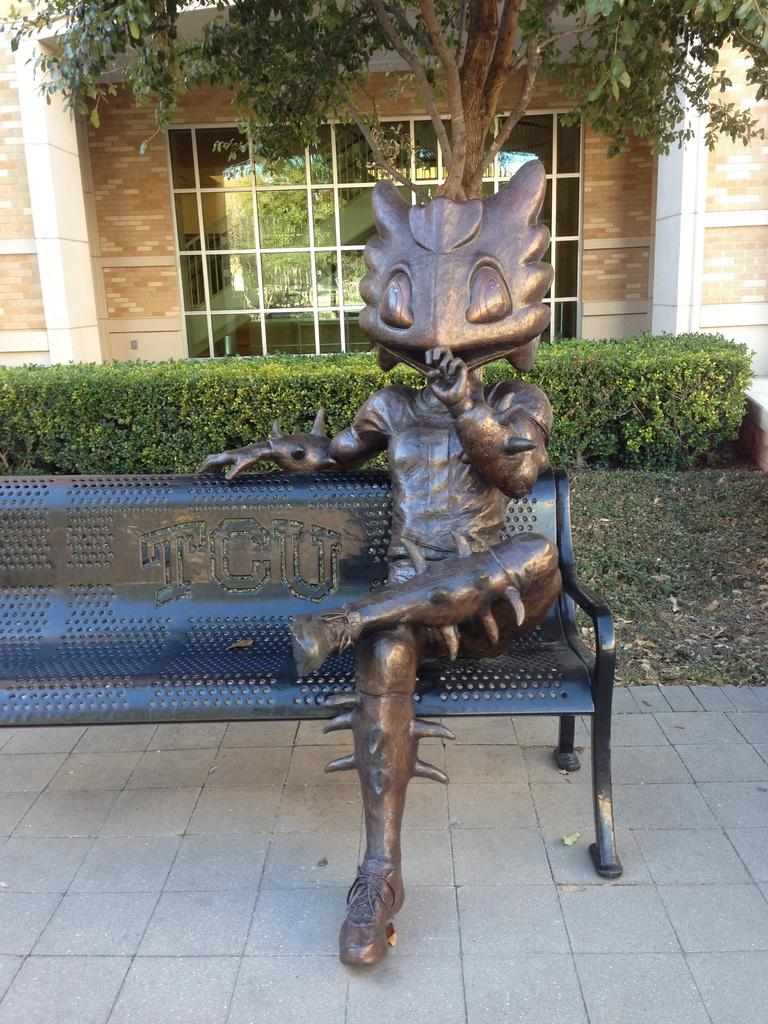What is on the bench in the image? There is a statue on a bench in the image. What can be seen behind the bench? There are plants and a tree behind the bench. What is the wall behind the bench made of? The wall behind the bench has a glass window. What can be seen through the glass window? The staircase is visible through the glass window. What type of fuel is being used to power the statue in the image? There is no indication in the image that the statue requires fuel to function, as it is a static object. 